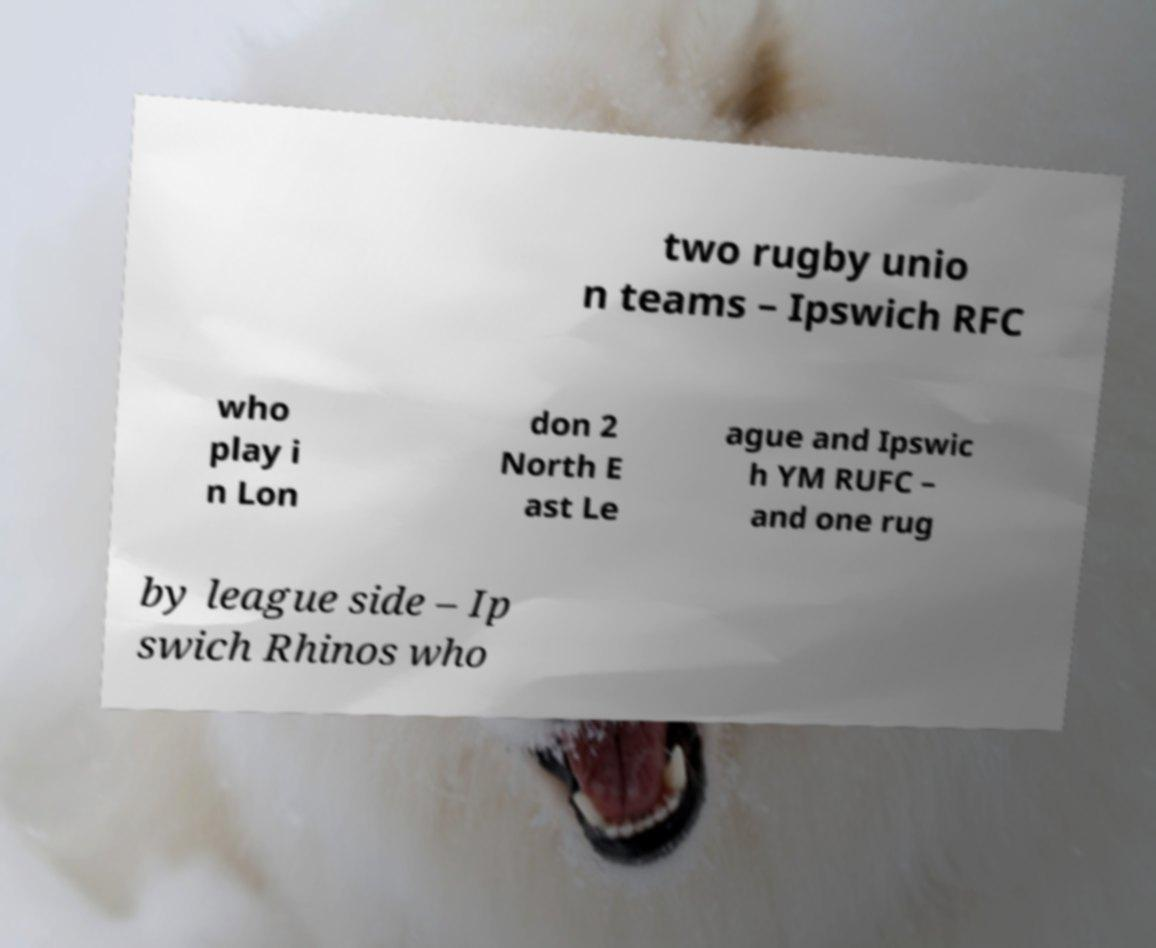Please read and relay the text visible in this image. What does it say? two rugby unio n teams – Ipswich RFC who play i n Lon don 2 North E ast Le ague and Ipswic h YM RUFC – and one rug by league side – Ip swich Rhinos who 